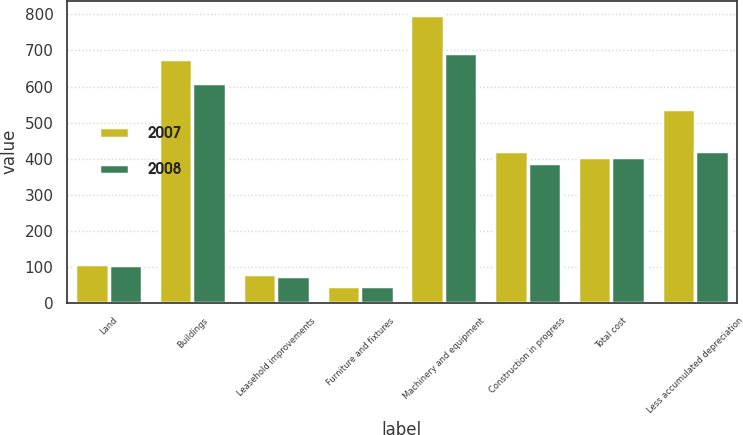Convert chart. <chart><loc_0><loc_0><loc_500><loc_500><stacked_bar_chart><ecel><fcel>Land<fcel>Buildings<fcel>Leasehold improvements<fcel>Furniture and fixtures<fcel>Machinery and equipment<fcel>Construction in progress<fcel>Total cost<fcel>Less accumulated depreciation<nl><fcel>2007<fcel>108.8<fcel>676.1<fcel>80.1<fcel>48.1<fcel>798.5<fcel>420.2<fcel>404.2<fcel>537<nl><fcel>2008<fcel>104.8<fcel>610.1<fcel>75.6<fcel>46.1<fcel>692.9<fcel>388.2<fcel>404.2<fcel>420.3<nl></chart> 